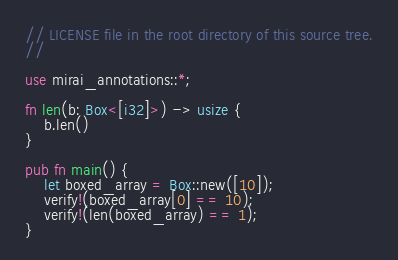Convert code to text. <code><loc_0><loc_0><loc_500><loc_500><_Rust_>// LICENSE file in the root directory of this source tree.
//

use mirai_annotations::*;

fn len(b: Box<[i32]>) -> usize {
    b.len()
}

pub fn main() {
    let boxed_array = Box::new([10]);
    verify!(boxed_array[0] == 10);
    verify!(len(boxed_array) == 1);
}
</code> 